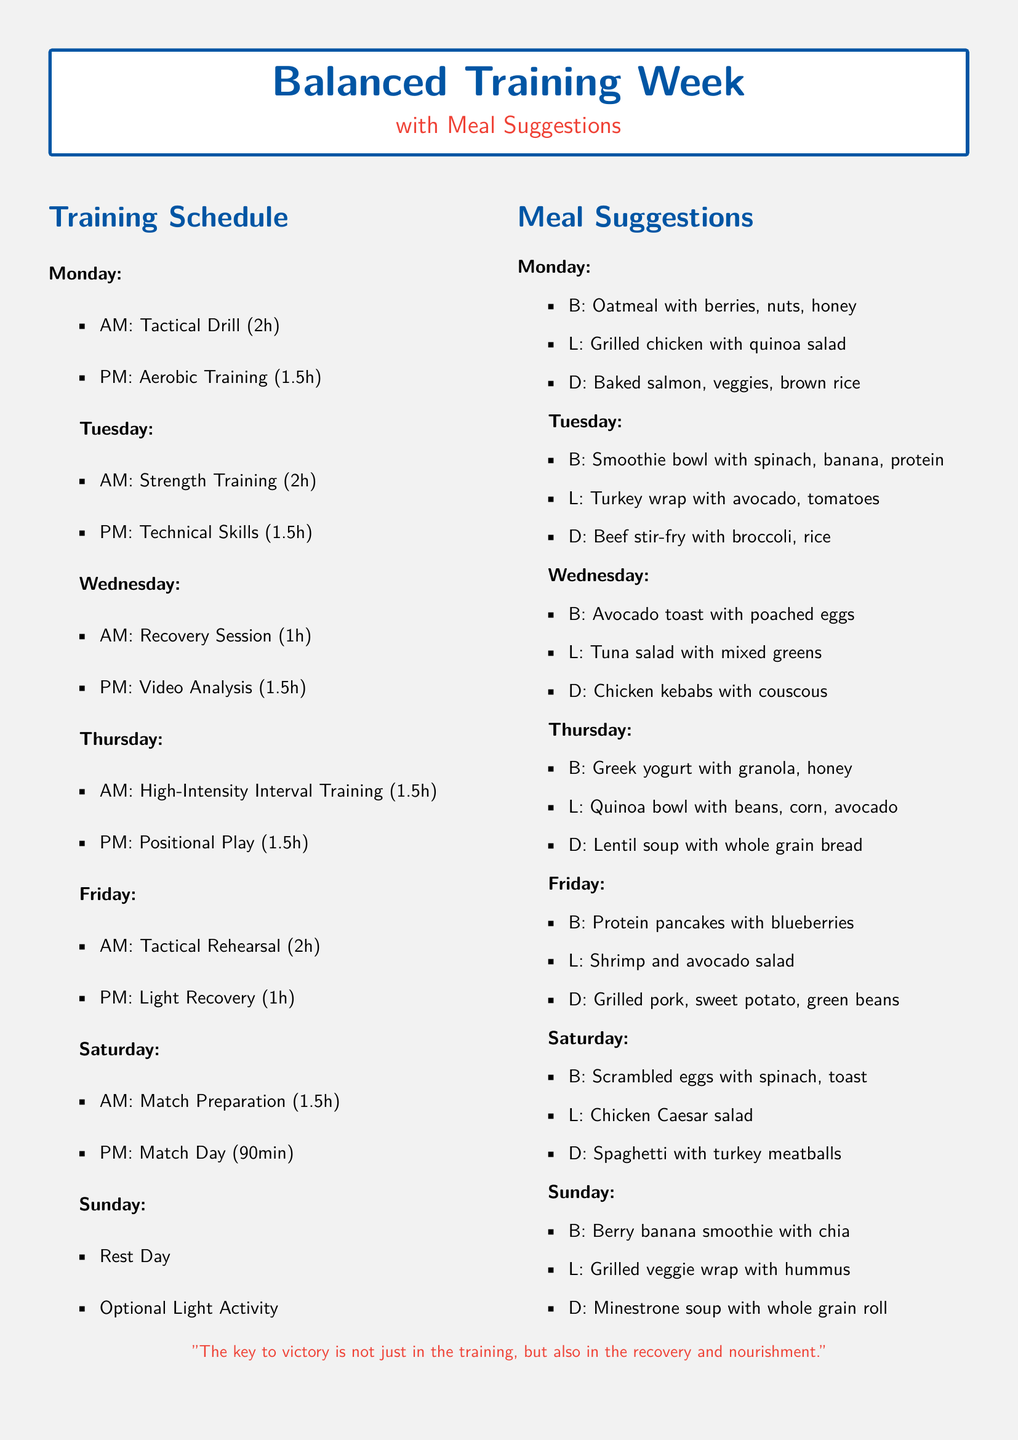What is the duration of the Tactical Drill? The duration for the Tactical Drill on Monday is specified in the document, which states that it lasts for 2 hours.
Answer: 2h What type of training is scheduled for Tuesday PM? According to the document, Tuesday PM is reserved for Technical Skills training, which is part of the training schedule.
Answer: Technical Skills What meal is suggested for breakfast on Wednesday? The document lists specific meals for each day, and for Wednesday breakfast, it suggests Avocado toast with poached eggs.
Answer: Avocado toast with poached eggs How many hours are dedicated to Recovery Session on Wednesday? Wednesday's schedule includes a Recovery Session with a duration detailed in the document, which shows it lasts for 1 hour.
Answer: 1h What is the focus of training for Thursday AM? The document specifies that Thursday AM is focused on High-Intensity Interval Training, indicating the type of training planned.
Answer: High-Intensity Interval Training What is the suggested dinner on Saturday? The document provides dinner suggestions, and for Saturday, it suggests Spaghetti with turkey meatballs as the meal.
Answer: Spaghetti with turkey meatballs What activity is listed for Sunday? The document indicates that Sunday is designated as a Rest Day with the option for Optional Light Activity.
Answer: Rest Day How many meals are listed for each day? The document details meals for each day, showing that there are three meals suggested per day, which counts them clearly.
Answer: Three What is the quote at the bottom of the document? The document concludes with a motivational quote related to training and nutrition, and it says, "The key to victory is not just in the training, but also in the recovery and nourishment."
Answer: The key to victory is not just in the training, but also in the recovery and nourishment 